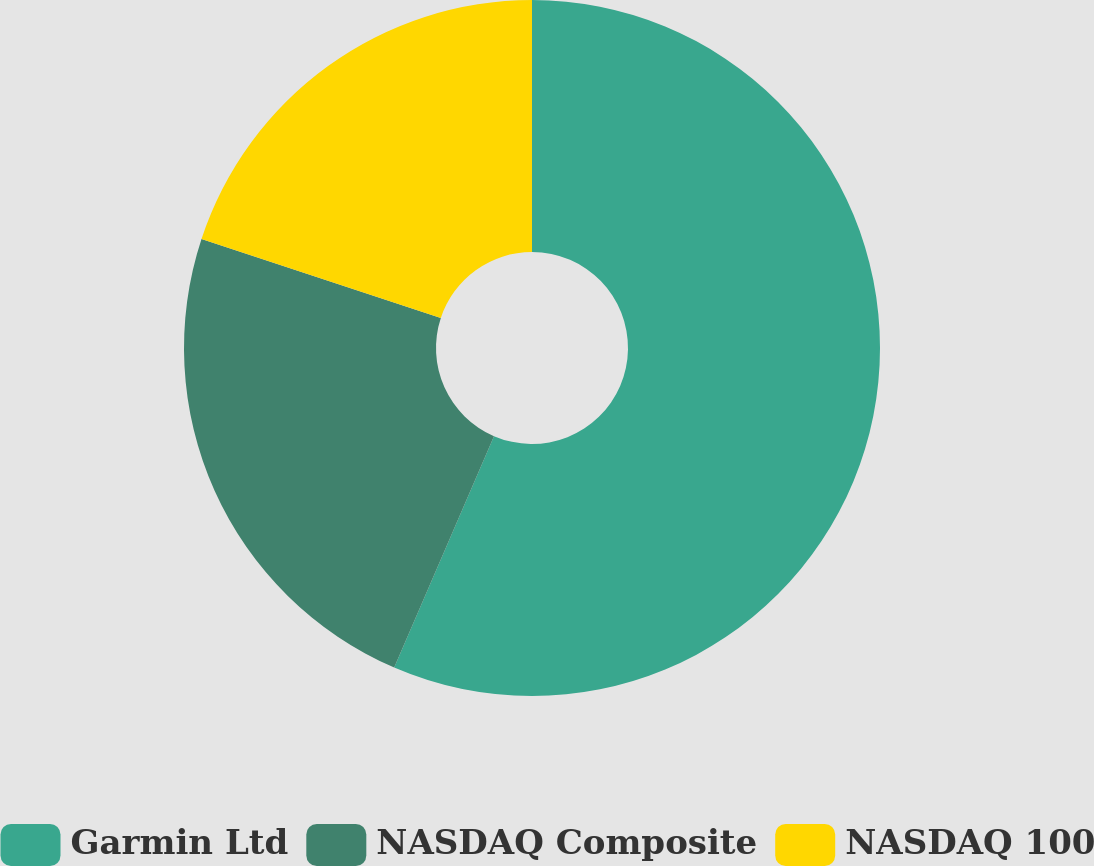Convert chart to OTSL. <chart><loc_0><loc_0><loc_500><loc_500><pie_chart><fcel>Garmin Ltd<fcel>NASDAQ Composite<fcel>NASDAQ 100<nl><fcel>56.48%<fcel>23.59%<fcel>19.93%<nl></chart> 